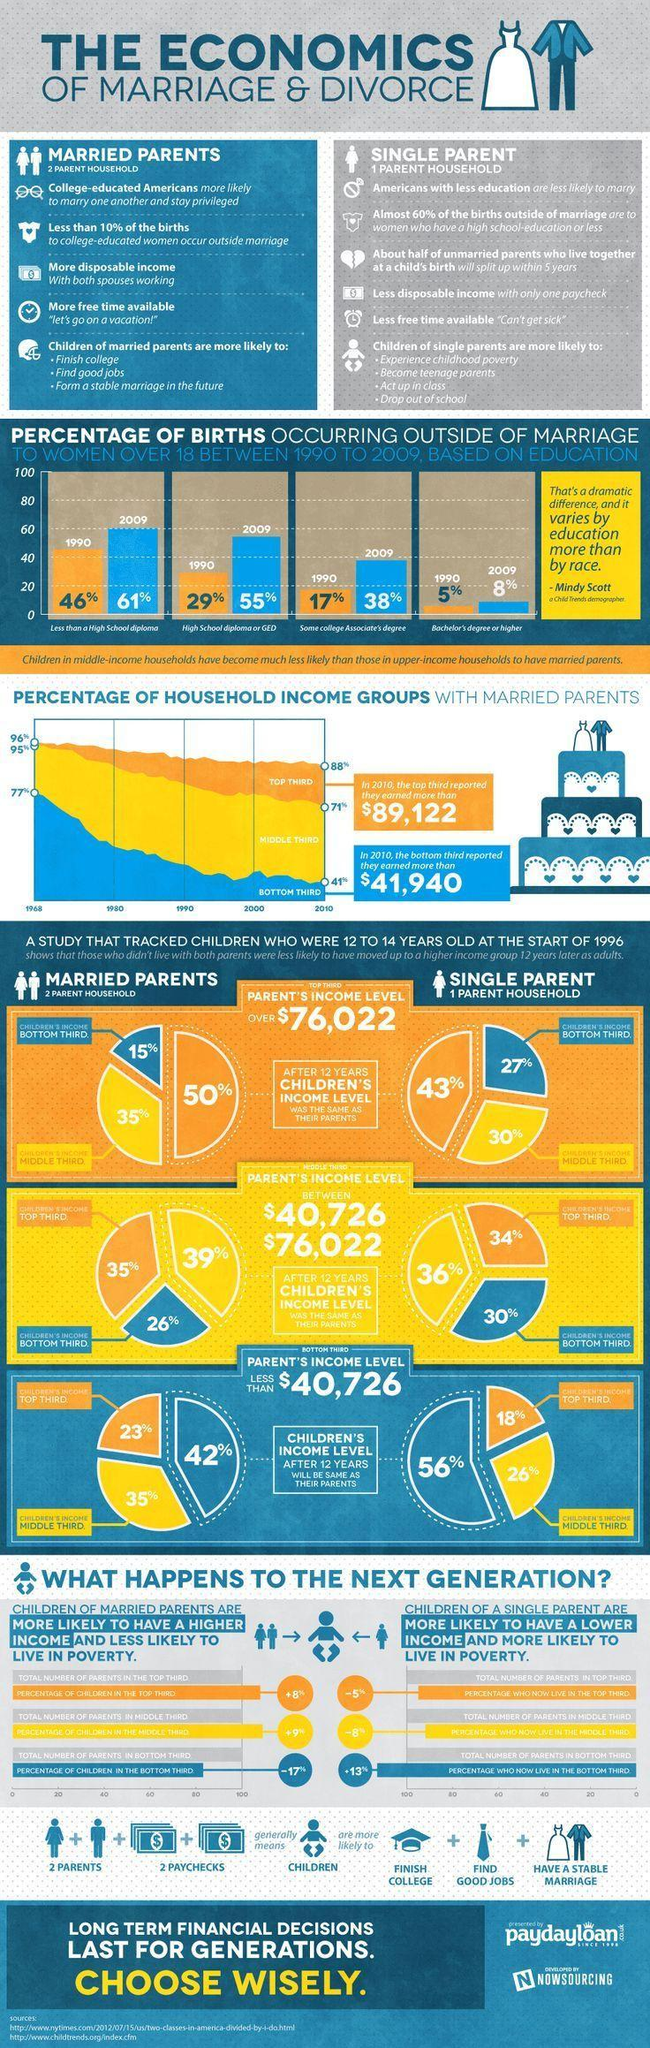What is the percentage of births occurring outside of marriage in 1990  when less than a high school diploma and high school diploma took together?
Answer the question with a short phrase. 75% How many points are under the heading married parents? 5 What is the percentage of births occurring outside of marriage in 2009 when less than a high school diploma and high school diploma took together? 116% How many points are under the heading single parent? 6 